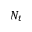Convert formula to latex. <formula><loc_0><loc_0><loc_500><loc_500>N _ { t }</formula> 